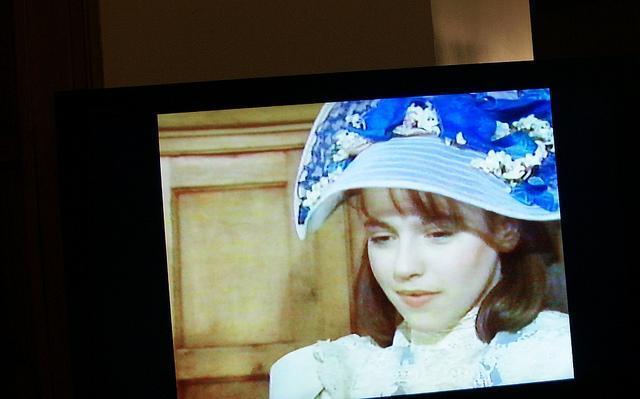How many surfboards are there?
Give a very brief answer. 0. 